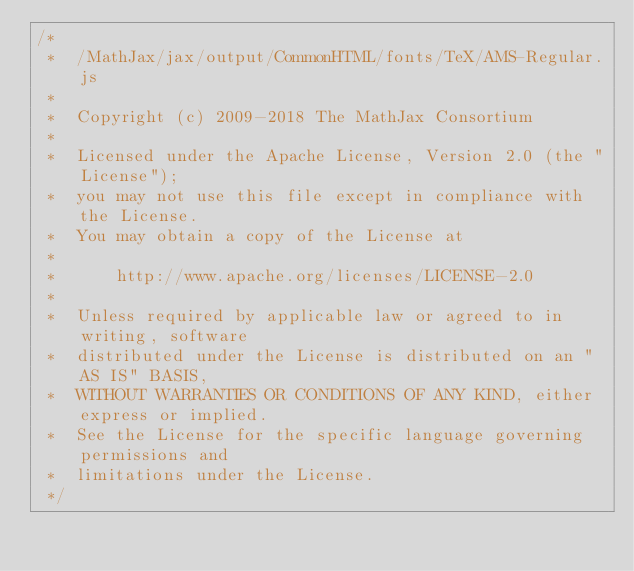<code> <loc_0><loc_0><loc_500><loc_500><_JavaScript_>/*
 *  /MathJax/jax/output/CommonHTML/fonts/TeX/AMS-Regular.js
 *
 *  Copyright (c) 2009-2018 The MathJax Consortium
 *
 *  Licensed under the Apache License, Version 2.0 (the "License");
 *  you may not use this file except in compliance with the License.
 *  You may obtain a copy of the License at
 *
 *      http://www.apache.org/licenses/LICENSE-2.0
 *
 *  Unless required by applicable law or agreed to in writing, software
 *  distributed under the License is distributed on an "AS IS" BASIS,
 *  WITHOUT WARRANTIES OR CONDITIONS OF ANY KIND, either express or implied.
 *  See the License for the specific language governing permissions and
 *  limitations under the License.
 */
</code> 